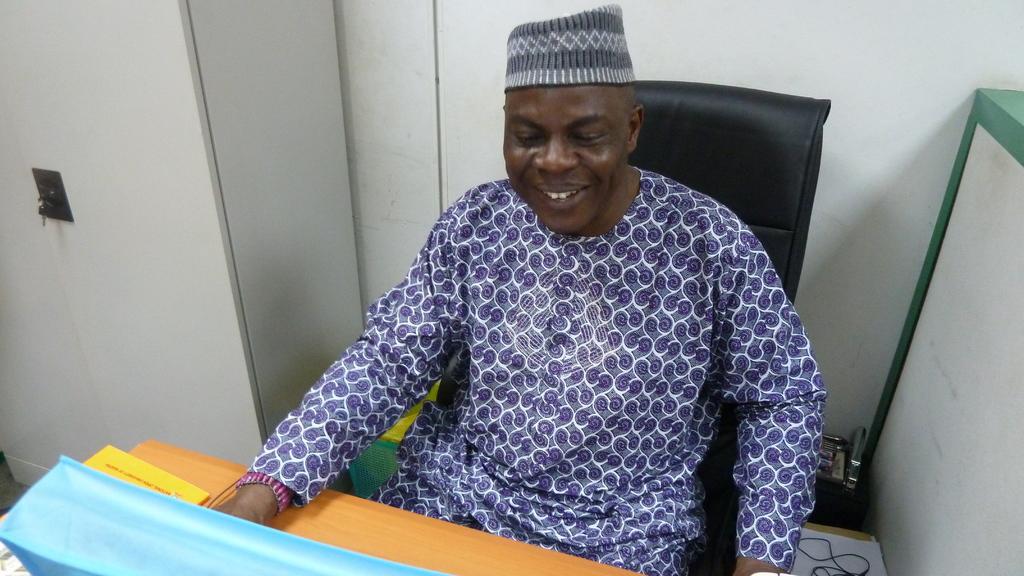In one or two sentences, can you explain what this image depicts? In a room there is a man sitting on a chair in front of the table,he is wearing a purple and white dress and beside the man there is white cupboard and in the background there is a wall. 